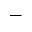<formula> <loc_0><loc_0><loc_500><loc_500>\_</formula> 